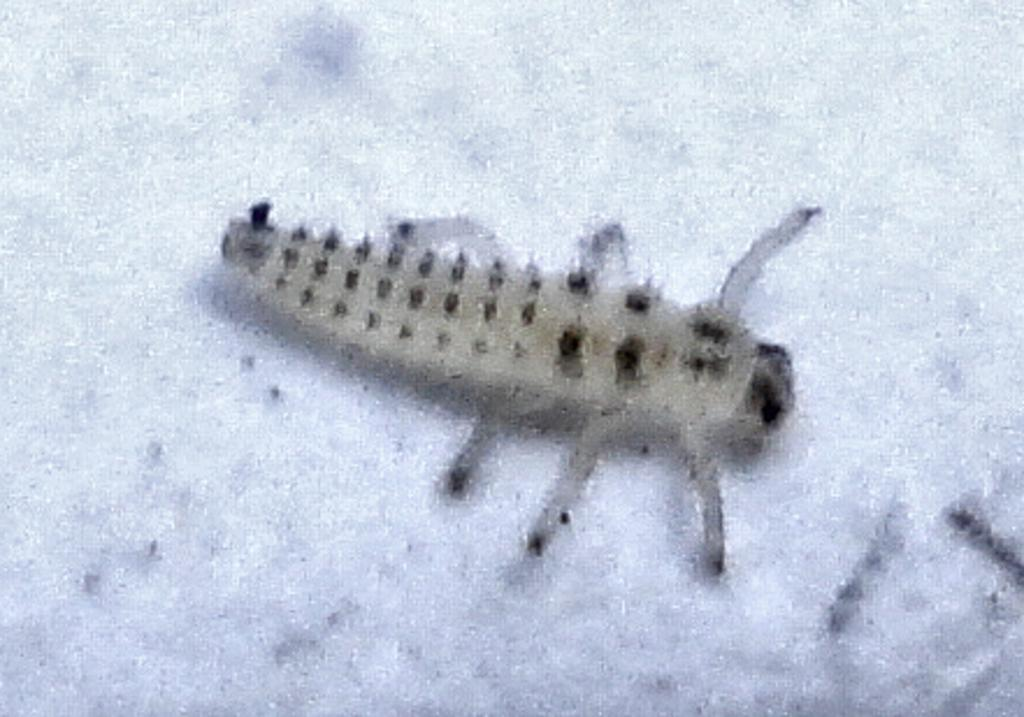What type of creature can be seen in the image? There is an insect in the picture. What color is the background of the image? The background of the image is white. Can you describe the overall clarity of the image? The image is partially blurred. What type of baseball equipment can be seen in the image? There is no baseball equipment present in the image; it features an insect and a white background. What type of pin is visible in the image? There is no pin present in the image. 